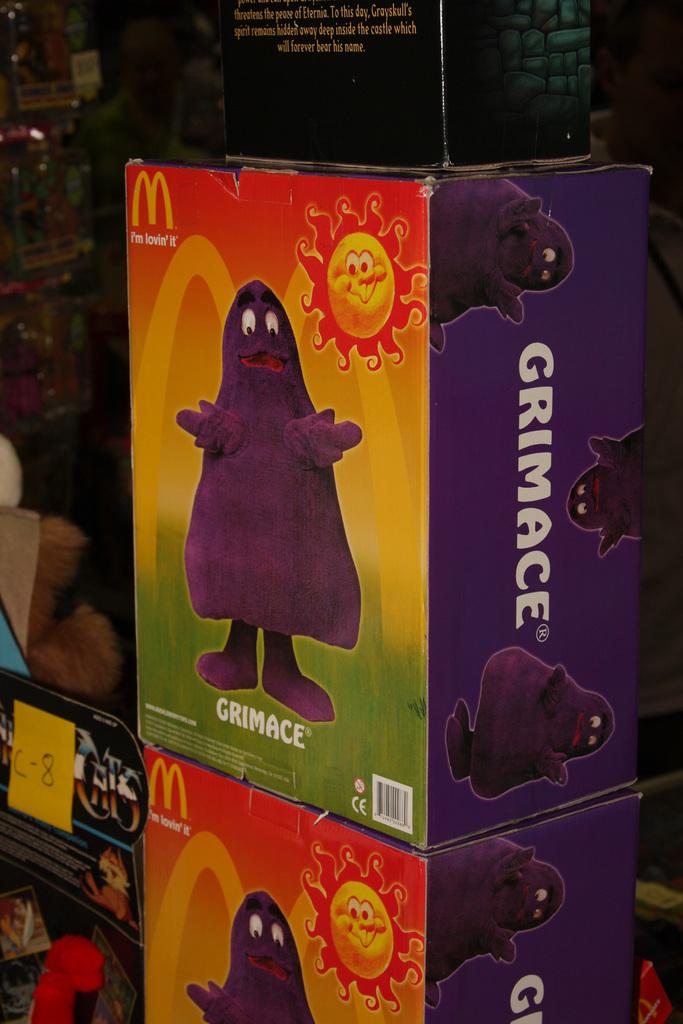What character is on the box?
Make the answer very short. Grimace. What is the restaurant logo shown on the box?
Your answer should be compact. Mcdonalds. 